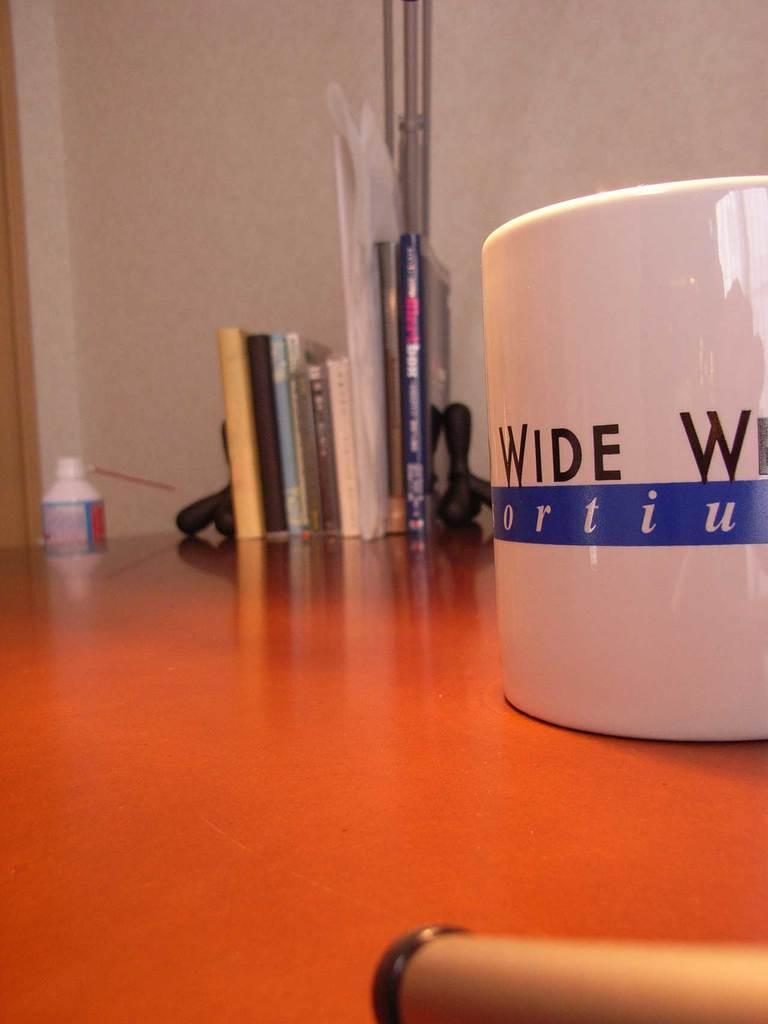Describe this image in one or two sentences. In this picture i could see a cup. On this cup there is some text and this cup is on the table top. In the middle of the picture i could see some books on the table top and there is a wall in the background. There is a book holder which are black in color to the sides of the book. The table is red in color. 